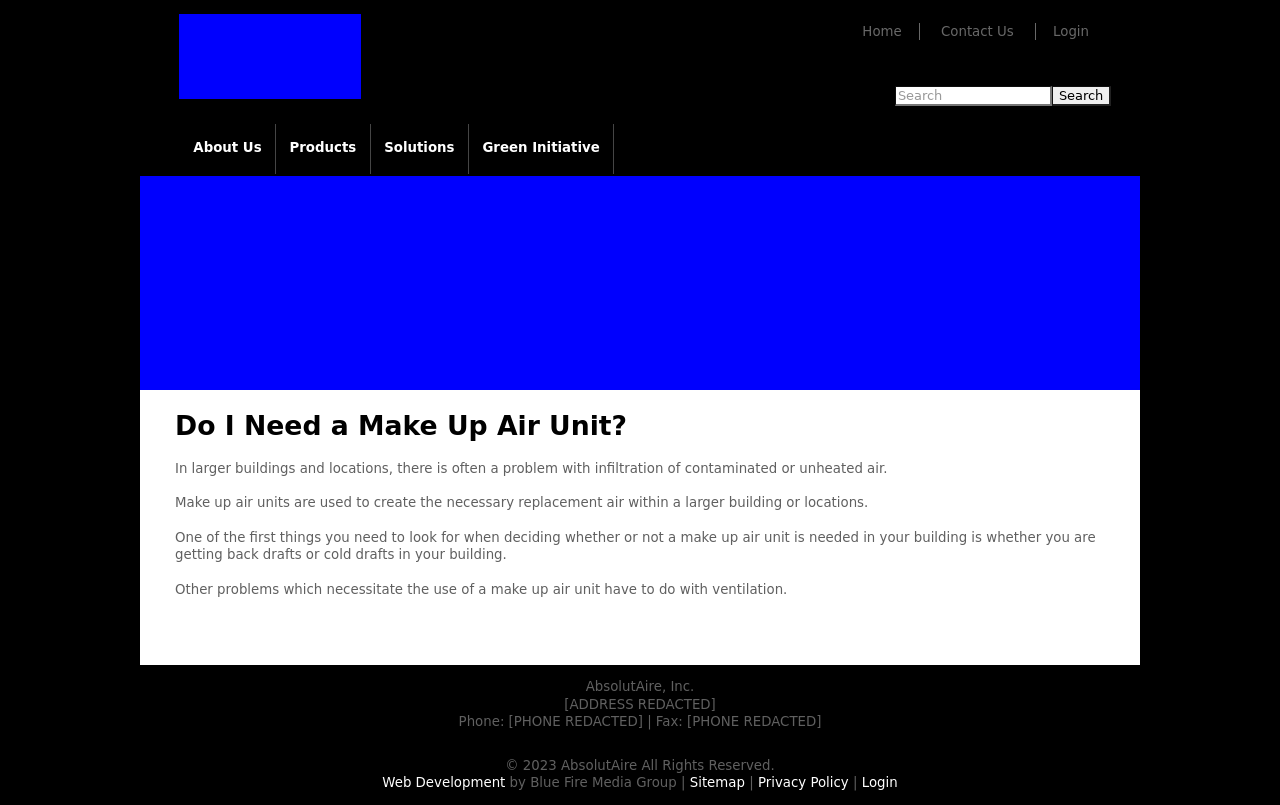Can you explain the importance of the 'Make Up Air Unit' section in the context of the website? The 'Do I Need a Make Up Air Unit?' section in the website is crucial as it addresses common concerns regarding air quality and temperature control in large spaces, which is a key area of expertise for the company represented. Providing this information helps establish the company's authority in this field and acts as a valuable resource for potential clients wondering about such installations. It likely assists in lead generation by engaging users who are researching solutions to their specific needs related to air handling and purification. 